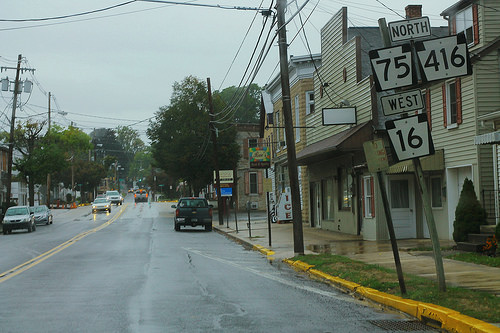<image>
Is there a truck next to the car? No. The truck is not positioned next to the car. They are located in different areas of the scene. 